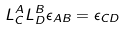<formula> <loc_0><loc_0><loc_500><loc_500>L _ { C } ^ { A } L _ { D } ^ { B } \epsilon _ { A B } = \epsilon _ { C D }</formula> 